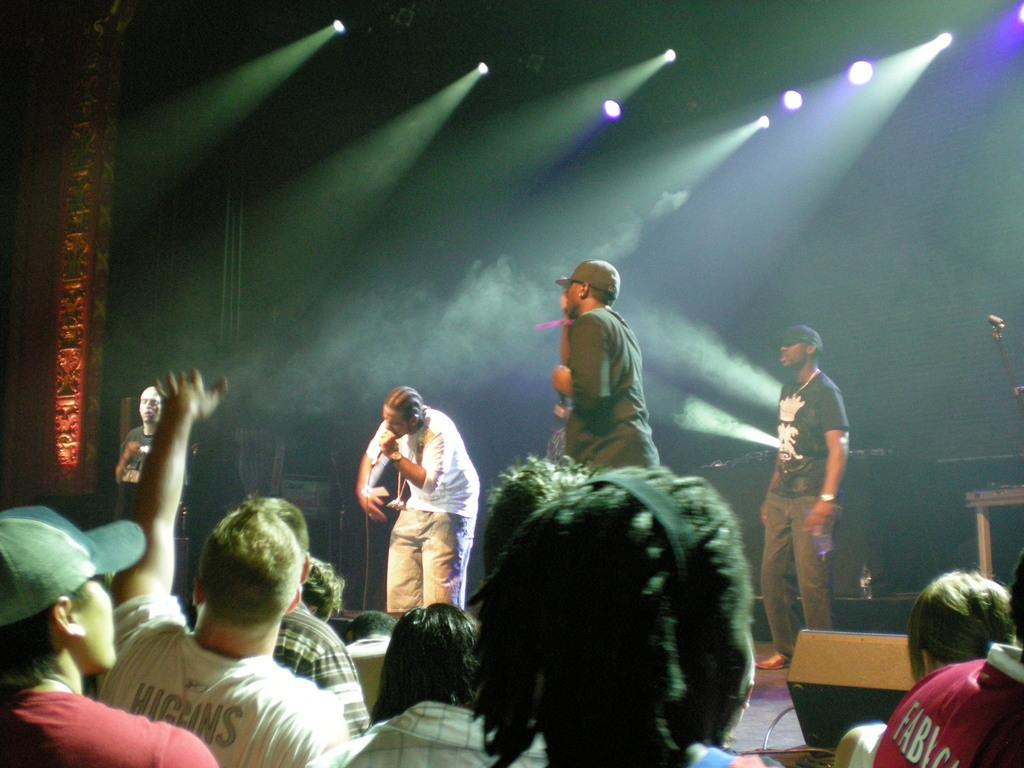Could you give a brief overview of what you see in this image? This looks like a musical concert. There are some persons on the stage. One of them is holding a mic. There are lights at the top. There are some persons at the bottom. 